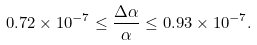<formula> <loc_0><loc_0><loc_500><loc_500>0 . 7 2 \times 1 0 ^ { - 7 } \leq \frac { \Delta \alpha } { \alpha } \leq 0 . 9 3 \times 1 0 ^ { - 7 } .</formula> 